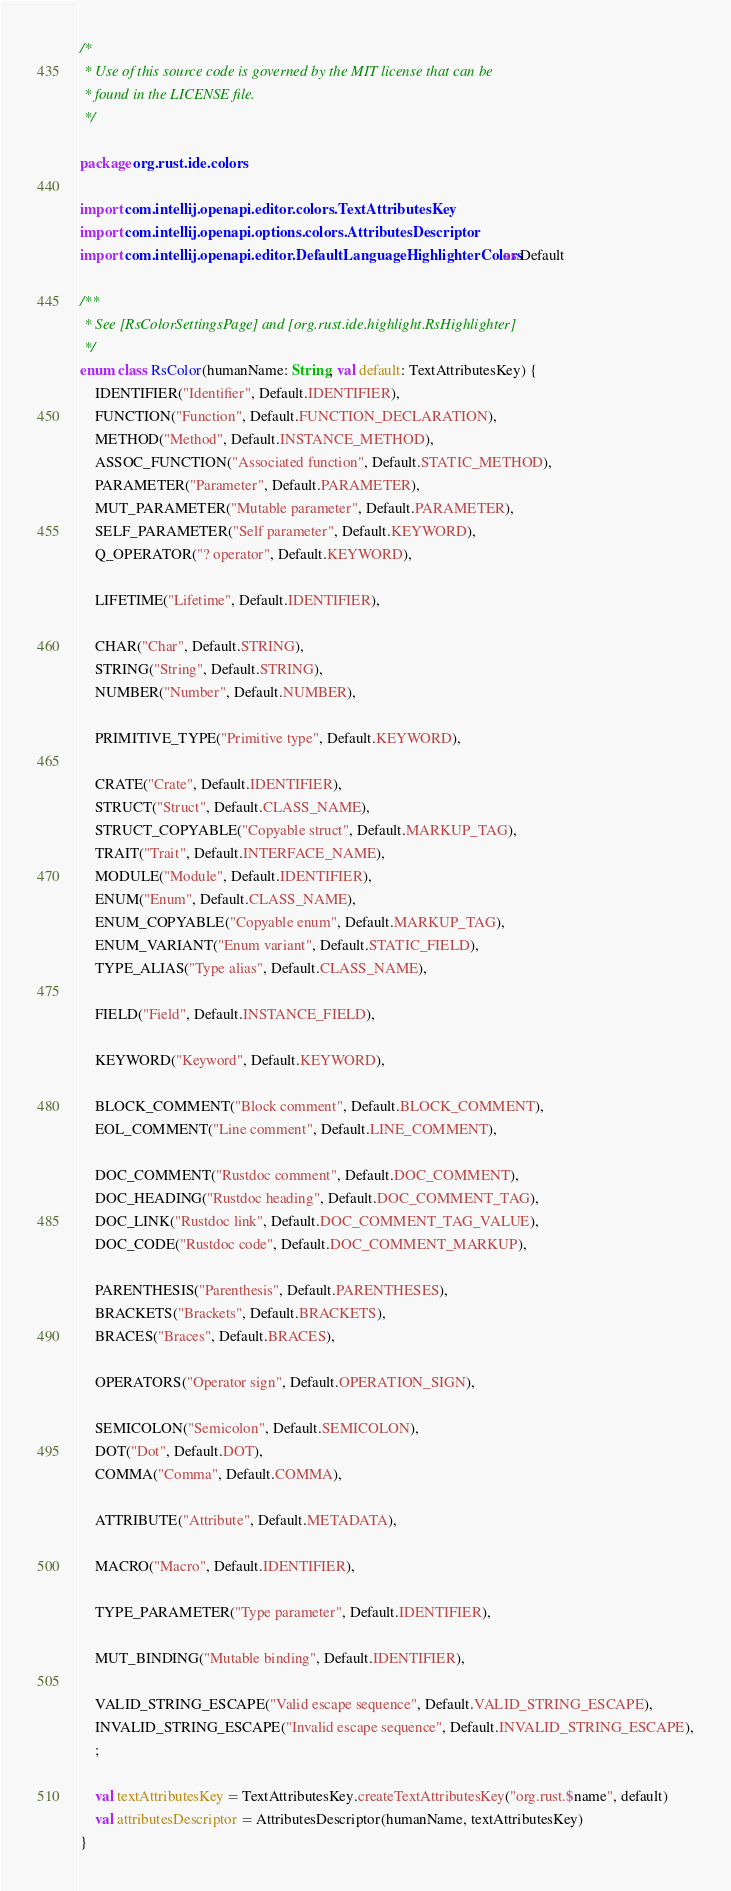Convert code to text. <code><loc_0><loc_0><loc_500><loc_500><_Kotlin_>/*
 * Use of this source code is governed by the MIT license that can be
 * found in the LICENSE file.
 */

package org.rust.ide.colors

import com.intellij.openapi.editor.colors.TextAttributesKey
import com.intellij.openapi.options.colors.AttributesDescriptor
import com.intellij.openapi.editor.DefaultLanguageHighlighterColors as Default

/**
 * See [RsColorSettingsPage] and [org.rust.ide.highlight.RsHighlighter]
 */
enum class RsColor(humanName: String, val default: TextAttributesKey) {
    IDENTIFIER("Identifier", Default.IDENTIFIER),
    FUNCTION("Function", Default.FUNCTION_DECLARATION),
    METHOD("Method", Default.INSTANCE_METHOD),
    ASSOC_FUNCTION("Associated function", Default.STATIC_METHOD),
    PARAMETER("Parameter", Default.PARAMETER),
    MUT_PARAMETER("Mutable parameter", Default.PARAMETER),
    SELF_PARAMETER("Self parameter", Default.KEYWORD),
    Q_OPERATOR("? operator", Default.KEYWORD),

    LIFETIME("Lifetime", Default.IDENTIFIER),

    CHAR("Char", Default.STRING),
    STRING("String", Default.STRING),
    NUMBER("Number", Default.NUMBER),

    PRIMITIVE_TYPE("Primitive type", Default.KEYWORD),

    CRATE("Crate", Default.IDENTIFIER),
    STRUCT("Struct", Default.CLASS_NAME),
    STRUCT_COPYABLE("Copyable struct", Default.MARKUP_TAG),
    TRAIT("Trait", Default.INTERFACE_NAME),
    MODULE("Module", Default.IDENTIFIER),
    ENUM("Enum", Default.CLASS_NAME),
    ENUM_COPYABLE("Copyable enum", Default.MARKUP_TAG),
    ENUM_VARIANT("Enum variant", Default.STATIC_FIELD),
    TYPE_ALIAS("Type alias", Default.CLASS_NAME),

    FIELD("Field", Default.INSTANCE_FIELD),

    KEYWORD("Keyword", Default.KEYWORD),

    BLOCK_COMMENT("Block comment", Default.BLOCK_COMMENT),
    EOL_COMMENT("Line comment", Default.LINE_COMMENT),

    DOC_COMMENT("Rustdoc comment", Default.DOC_COMMENT),
    DOC_HEADING("Rustdoc heading", Default.DOC_COMMENT_TAG),
    DOC_LINK("Rustdoc link", Default.DOC_COMMENT_TAG_VALUE),
    DOC_CODE("Rustdoc code", Default.DOC_COMMENT_MARKUP),

    PARENTHESIS("Parenthesis", Default.PARENTHESES),
    BRACKETS("Brackets", Default.BRACKETS),
    BRACES("Braces", Default.BRACES),

    OPERATORS("Operator sign", Default.OPERATION_SIGN),

    SEMICOLON("Semicolon", Default.SEMICOLON),
    DOT("Dot", Default.DOT),
    COMMA("Comma", Default.COMMA),

    ATTRIBUTE("Attribute", Default.METADATA),

    MACRO("Macro", Default.IDENTIFIER),

    TYPE_PARAMETER("Type parameter", Default.IDENTIFIER),

    MUT_BINDING("Mutable binding", Default.IDENTIFIER),

    VALID_STRING_ESCAPE("Valid escape sequence", Default.VALID_STRING_ESCAPE),
    INVALID_STRING_ESCAPE("Invalid escape sequence", Default.INVALID_STRING_ESCAPE),
    ;

    val textAttributesKey = TextAttributesKey.createTextAttributesKey("org.rust.$name", default)
    val attributesDescriptor = AttributesDescriptor(humanName, textAttributesKey)
}

</code> 